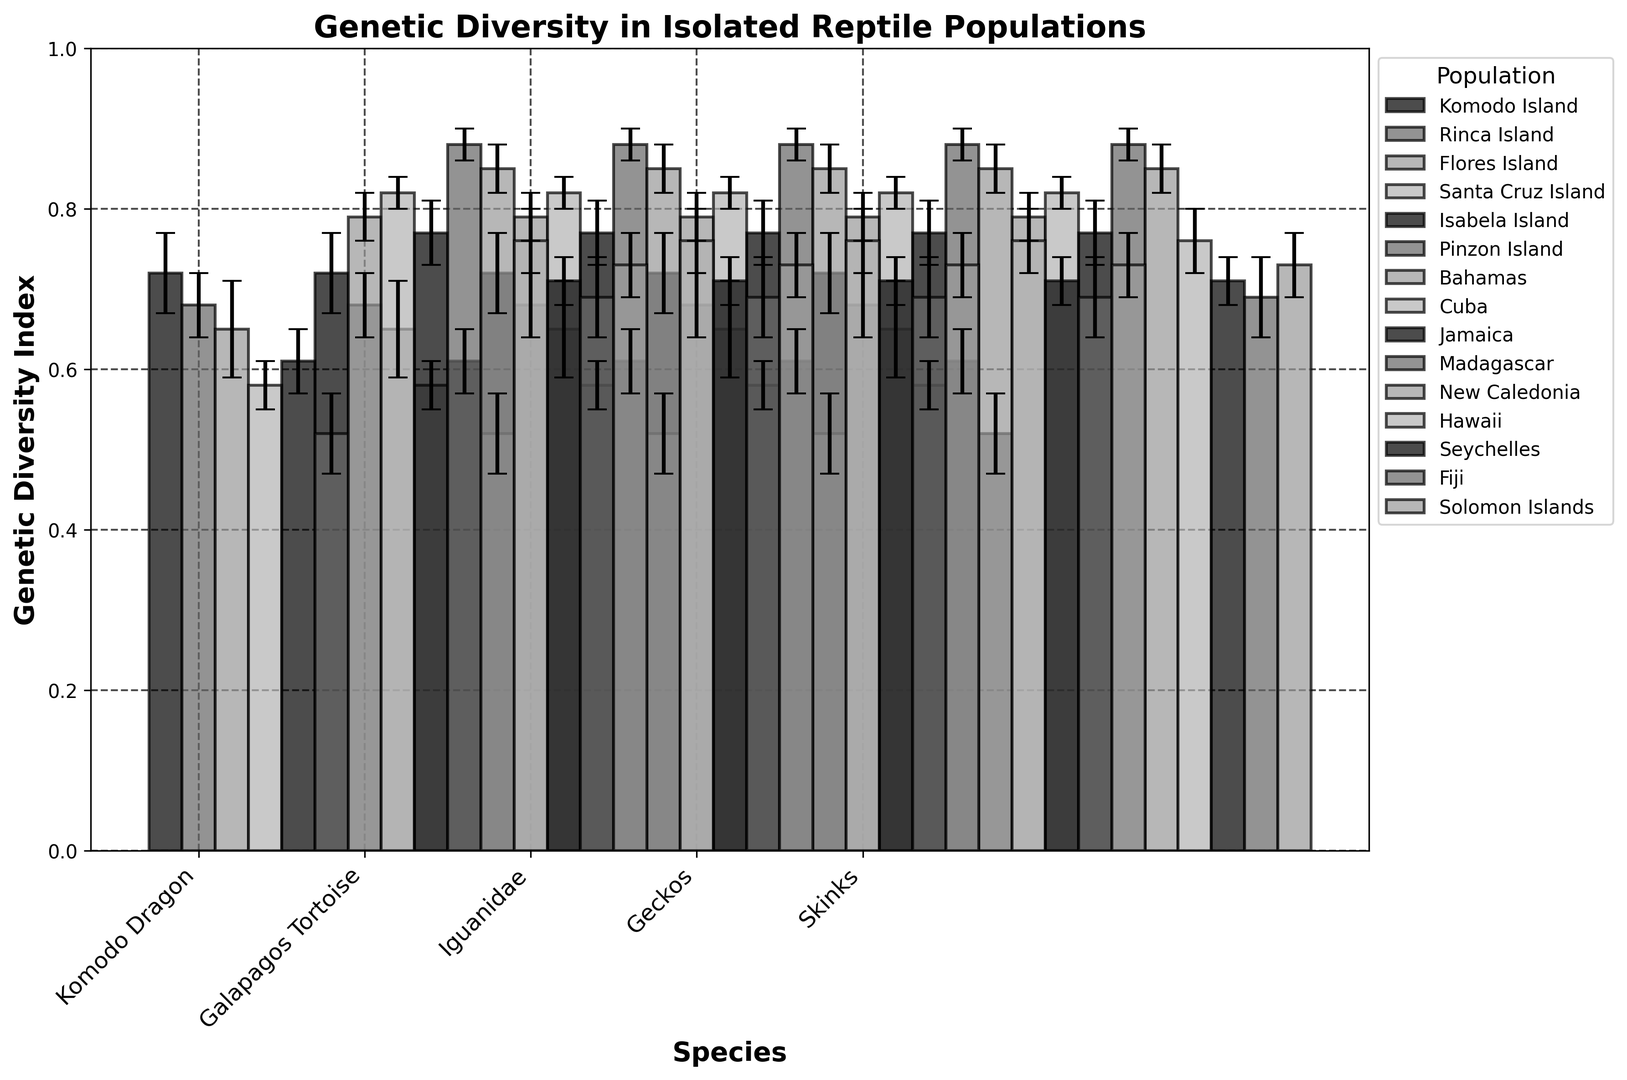Which species has the highest genetic diversity index? The highest bar represents the highest genetic diversity index. By observing the figure, the Geckos species has the tallest bar.
Answer: Geckos Which population of Komodo Dragons has the lowest genetic diversity index? Look at the bars corresponding to Komodo Dragons. The shortest bar among them is for the Flores Island population.
Answer: Flores Island What is the difference in genetic diversity index between the populations of Iguanidae in Cuba and Jamaica? Look at the bars for Iguanidae in Cuba and Jamaica. Subtract the height of the Jamaica bar from the height of the Cuba bar: 0.82 - 0.77 = 0.05.
Answer: 0.05 How many species have a genetic diversity index above 0.75? Identify the bars with a height greater than 0.75. Count the species labels corresponding to these bars.
Answer: 3 Which population has the highest genetic diversity index overall? Look for the tallest bar in the entire figure. The tallest bar represents the Geckos in Madagascar.
Answer: Madagascar What is the median genetic diversity index for the Galapagos Tortoise populations? Arrange the genetic diversity indices for all Galapagos Tortoise populations (0.58, 0.61, 0.52) in ascending order (0.52, 0.58, 0.61) and find the middle value.
Answer: 0.58 Compare the genetic diversity indices of Skinks in Fiji and Seychelles populations. Which one is greater and by how much? Look at the bars for Skinks in Fiji and Seychelles. Fiji has a genetic diversity index of 0.69 and Seychelles has 0.71. Subtract 0.69 from 0.71.
Answer: Seychelles, by 0.02 What is the average genetic diversity index for all populations of Geckos? Add the genetic diversity indices of all Geckos populations (0.88, 0.85, 0.76) and divide by the number of populations: (0.88 + 0.85 + 0.76) / 3 = 2.49 / 3.
Answer: 0.83 Which species shows the smallest variation in genetic diversity index across different populations, considering the error bars? Look at the error bars for each species. The species whose bars have the smallest length represent the smallest variation.
Answer: Iguanidae 